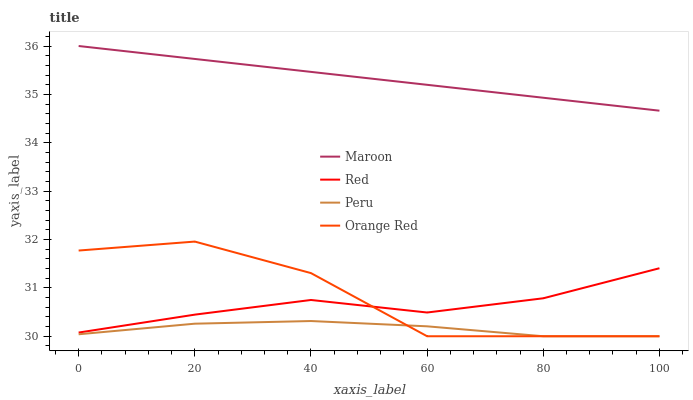Does Peru have the minimum area under the curve?
Answer yes or no. Yes. Does Maroon have the maximum area under the curve?
Answer yes or no. Yes. Does Red have the minimum area under the curve?
Answer yes or no. No. Does Red have the maximum area under the curve?
Answer yes or no. No. Is Maroon the smoothest?
Answer yes or no. Yes. Is Orange Red the roughest?
Answer yes or no. Yes. Is Red the smoothest?
Answer yes or no. No. Is Red the roughest?
Answer yes or no. No. Does Peru have the lowest value?
Answer yes or no. Yes. Does Red have the lowest value?
Answer yes or no. No. Does Maroon have the highest value?
Answer yes or no. Yes. Does Red have the highest value?
Answer yes or no. No. Is Peru less than Maroon?
Answer yes or no. Yes. Is Red greater than Peru?
Answer yes or no. Yes. Does Red intersect Orange Red?
Answer yes or no. Yes. Is Red less than Orange Red?
Answer yes or no. No. Is Red greater than Orange Red?
Answer yes or no. No. Does Peru intersect Maroon?
Answer yes or no. No. 